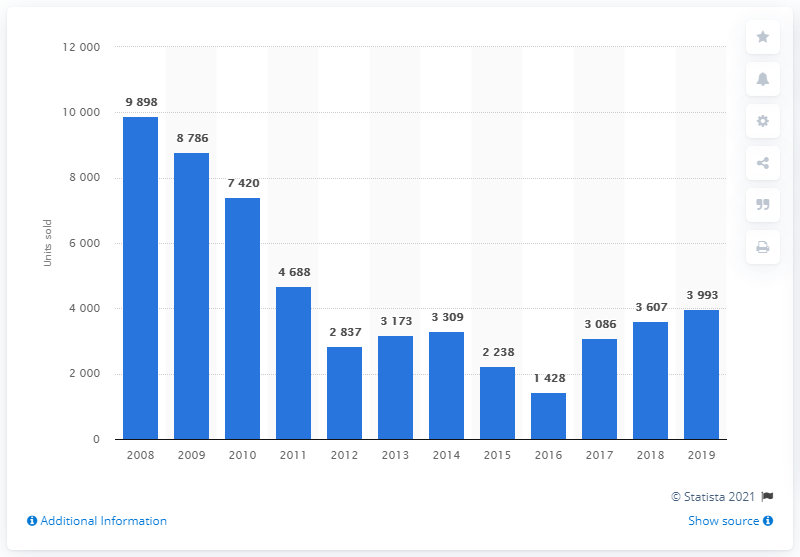Draw attention to some important aspects in this diagram. In 2008, the highest number of Skoda cars sold in Greece was 9,898. Skoda sold a total of 9,898 cars in Greece in 2019. 